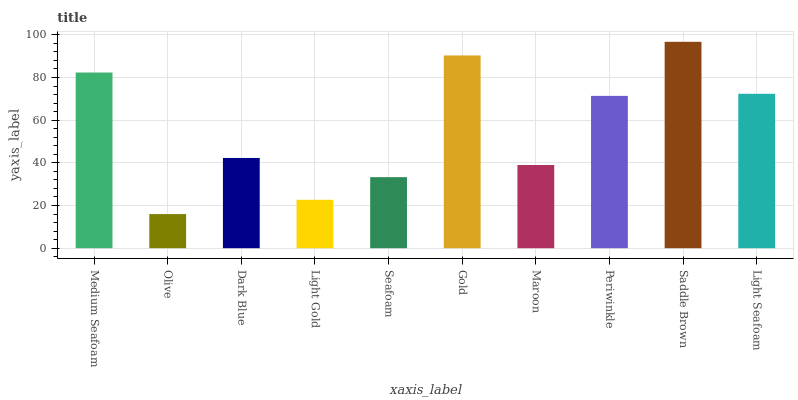Is Olive the minimum?
Answer yes or no. Yes. Is Saddle Brown the maximum?
Answer yes or no. Yes. Is Dark Blue the minimum?
Answer yes or no. No. Is Dark Blue the maximum?
Answer yes or no. No. Is Dark Blue greater than Olive?
Answer yes or no. Yes. Is Olive less than Dark Blue?
Answer yes or no. Yes. Is Olive greater than Dark Blue?
Answer yes or no. No. Is Dark Blue less than Olive?
Answer yes or no. No. Is Periwinkle the high median?
Answer yes or no. Yes. Is Dark Blue the low median?
Answer yes or no. Yes. Is Olive the high median?
Answer yes or no. No. Is Periwinkle the low median?
Answer yes or no. No. 